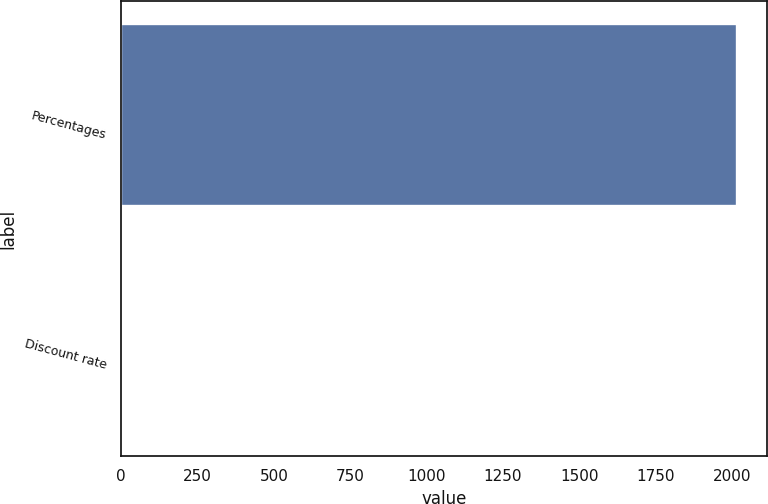Convert chart to OTSL. <chart><loc_0><loc_0><loc_500><loc_500><bar_chart><fcel>Percentages<fcel>Discount rate<nl><fcel>2014<fcel>3.6<nl></chart> 